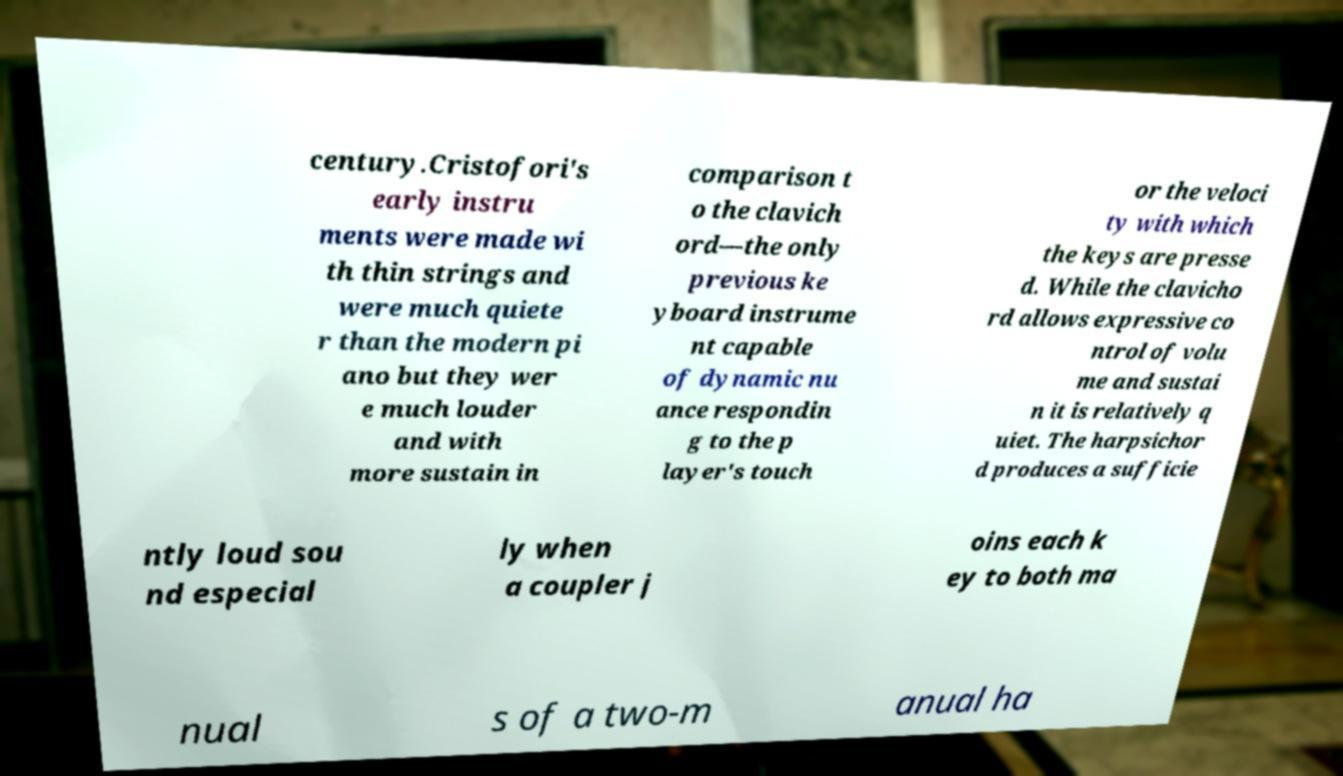I need the written content from this picture converted into text. Can you do that? century.Cristofori's early instru ments were made wi th thin strings and were much quiete r than the modern pi ano but they wer e much louder and with more sustain in comparison t o the clavich ord—the only previous ke yboard instrume nt capable of dynamic nu ance respondin g to the p layer's touch or the veloci ty with which the keys are presse d. While the clavicho rd allows expressive co ntrol of volu me and sustai n it is relatively q uiet. The harpsichor d produces a sufficie ntly loud sou nd especial ly when a coupler j oins each k ey to both ma nual s of a two-m anual ha 